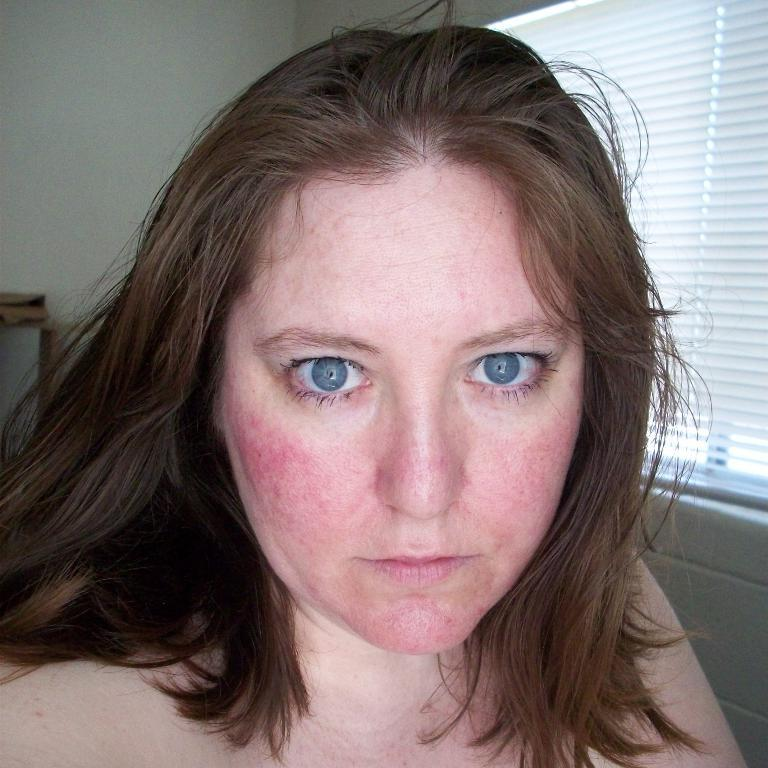What is the main subject of the image? There is a woman's face in the image. What can be seen in the background of the image? There is a wall in the background of the image. What is on the right side of the image? There is a curtain on the right side of the image. What is on the left side of the image? There is a table on the left side of the image. How many brothers does the woman in the image have? There is no information about the woman's brothers in the image. Is there any smoke visible in the image? There is no smoke present in the image. 